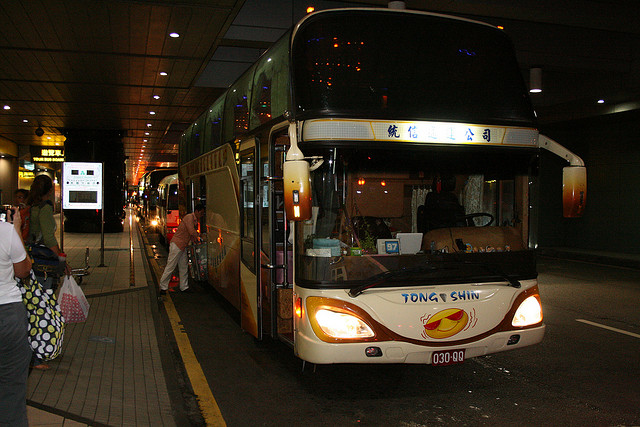Please extract the text content from this image. TONG SHIN 030 